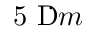Convert formula to latex. <formula><loc_0><loc_0><loc_500><loc_500>5 \text  mu  m</formula> 